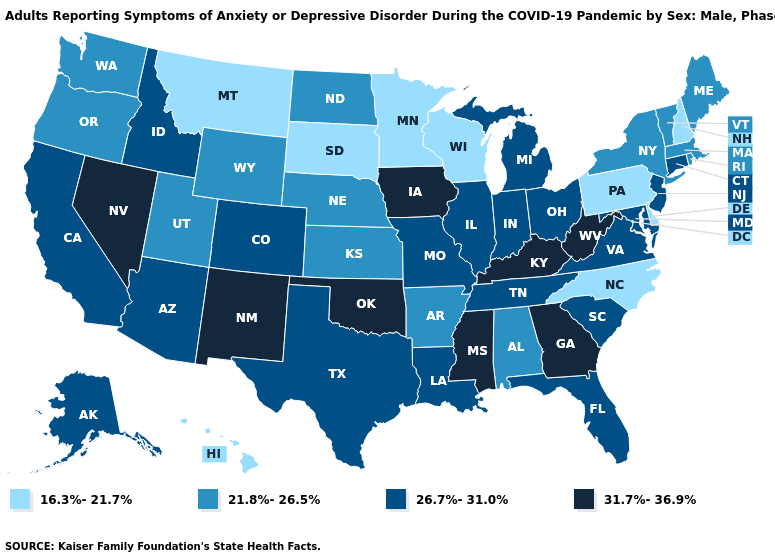Among the states that border Georgia , which have the highest value?
Be succinct. Florida, South Carolina, Tennessee. What is the value of Michigan?
Keep it brief. 26.7%-31.0%. Does the first symbol in the legend represent the smallest category?
Keep it brief. Yes. Name the states that have a value in the range 21.8%-26.5%?
Answer briefly. Alabama, Arkansas, Kansas, Maine, Massachusetts, Nebraska, New York, North Dakota, Oregon, Rhode Island, Utah, Vermont, Washington, Wyoming. How many symbols are there in the legend?
Quick response, please. 4. Does Alaska have a higher value than Maryland?
Concise answer only. No. What is the value of Colorado?
Give a very brief answer. 26.7%-31.0%. Which states have the highest value in the USA?
Concise answer only. Georgia, Iowa, Kentucky, Mississippi, Nevada, New Mexico, Oklahoma, West Virginia. Does Michigan have the highest value in the MidWest?
Short answer required. No. Does Minnesota have the lowest value in the USA?
Write a very short answer. Yes. Does the map have missing data?
Concise answer only. No. What is the lowest value in states that border Wyoming?
Concise answer only. 16.3%-21.7%. What is the value of Alabama?
Be succinct. 21.8%-26.5%. Name the states that have a value in the range 31.7%-36.9%?
Give a very brief answer. Georgia, Iowa, Kentucky, Mississippi, Nevada, New Mexico, Oklahoma, West Virginia. 